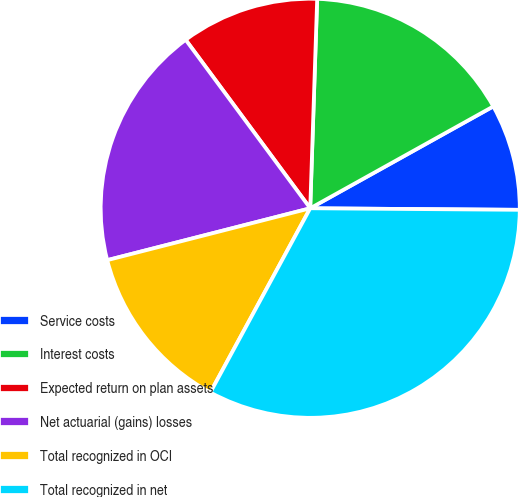Convert chart to OTSL. <chart><loc_0><loc_0><loc_500><loc_500><pie_chart><fcel>Service costs<fcel>Interest costs<fcel>Expected return on plan assets<fcel>Net actuarial (gains) losses<fcel>Total recognized in OCI<fcel>Total recognized in net<nl><fcel>8.2%<fcel>16.39%<fcel>10.66%<fcel>18.85%<fcel>13.11%<fcel>32.79%<nl></chart> 